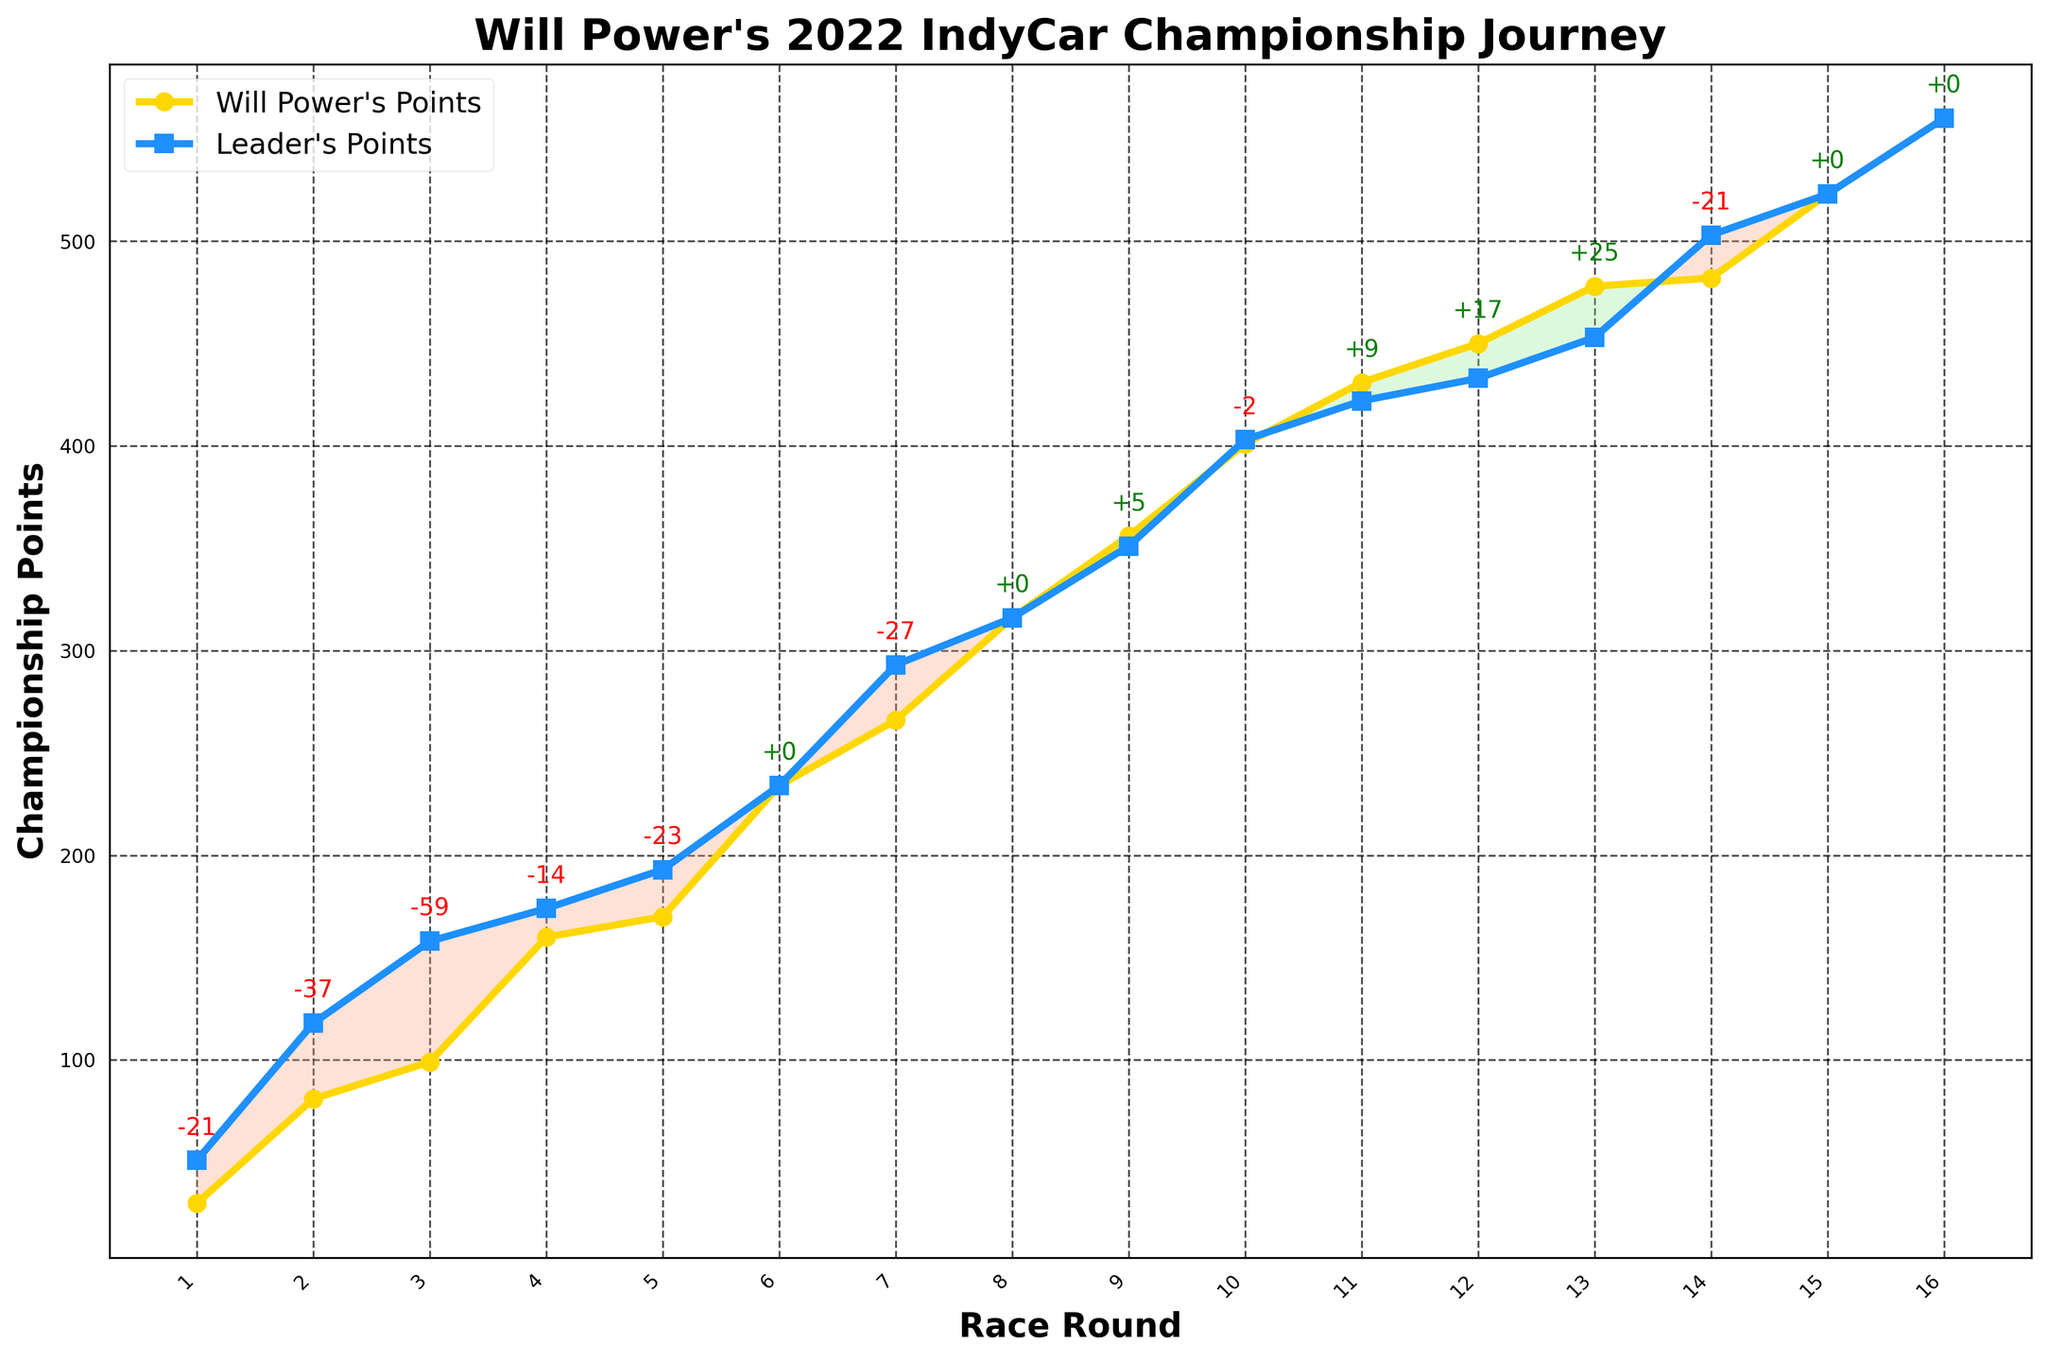What's the title of the chart? The title is located at the top of the chart, which reads "Will Power's 2022 IndyCar Championship Journey."
Answer: "Will Power's 2022 IndyCar Championship Journey" How many race rounds are displayed in the chart? The x-axis is labeled with race rounds and there are individual markers for each round from 1 to 16.
Answer: 16 What colors represent Will Power's and the leader's points? Will Power's points are represented in yellow, and the leader's points are in blue.
Answer: Yellow for Will Power, Blue for leader How many times did Will Power lead the championship points by the end of a round? The green shaded areas indicate instances where Will Power had more points than the leader. These occur during rounds 9, 11, 12, and 13.
Answer: 4 times At which rounds did Will Power and the leader have the same points? By comparing the plotted lines, we see they intersect at rounds 6, 8, 15, and 16, indicating equal points.
Answer: Rounds 6, 8, 15, 16 Which round shows the maximum points gap between Will Power and the leader? The points gap is annotated on the chart. The largest negative gap is -59 at round 3.
Answer: Round 3 How does the points gap change from Round 1 to Round 6 for Will Power? By following the annotated gaps on the chart: Round 1: -21, Round 2: -37, Round 3: -59, Round 4: -14, Round 5: -23, Round 6: 0. The gap starts at -21, increases (grows in negative direction) to -59, then decreases to 0 by Round 6.
Answer: Starts at -21 and goes to 0 What is the overall trend for Will Power's points throughout the championship? By observing the yellow line depicting Will Power's points, it shows a general upward trend from Round 1 to Round 16.
Answer: Upward trend When does Will Power first overtake the leader? The chart's annotations and green area indicate positive points gap (Will Power leading) first appear around Round 9.
Answer: Round 9 Which rounds have points gaps of zero? Points gaps of zero occur where the lines intersect, which are annotated as such in the chart at Rounds 6, 8, 15, and 16.
Answer: Rounds 6, 8, 15, 16 